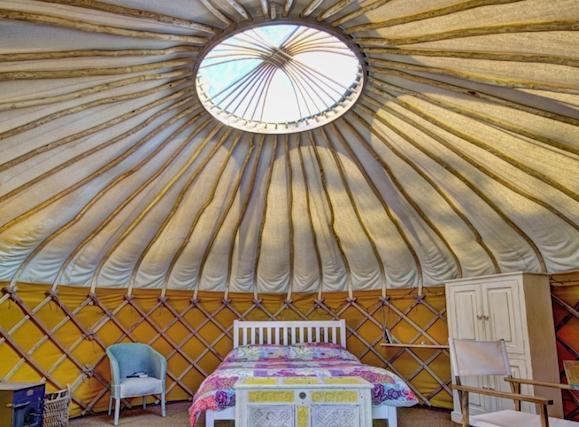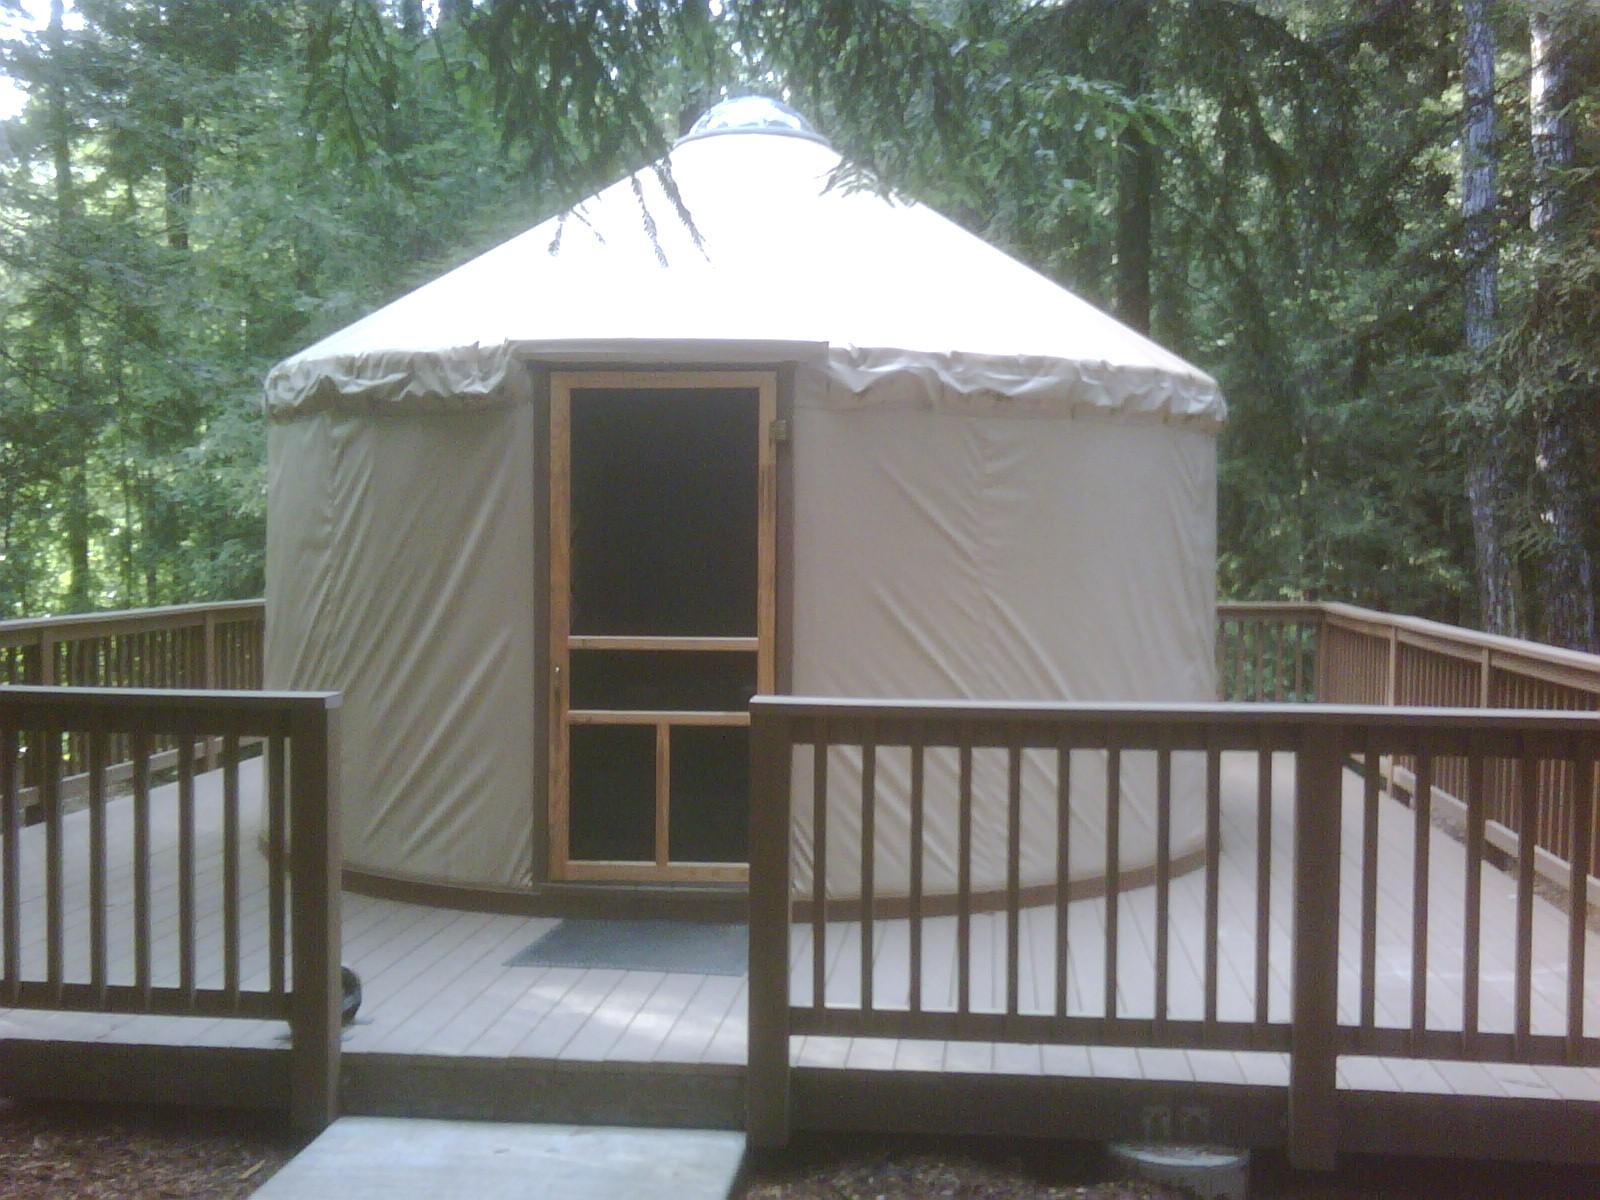The first image is the image on the left, the second image is the image on the right. Examine the images to the left and right. Is the description "Both images show the exterior of a dome-topped round building, its walls covered in white with a repeating blue symbol." accurate? Answer yes or no. No. The first image is the image on the left, the second image is the image on the right. Evaluate the accuracy of this statement regarding the images: "One interior image of a yurt shows a bedroom with one wide bed with a headboard and a trunk sitting at the end of the bed.". Is it true? Answer yes or no. Yes. 